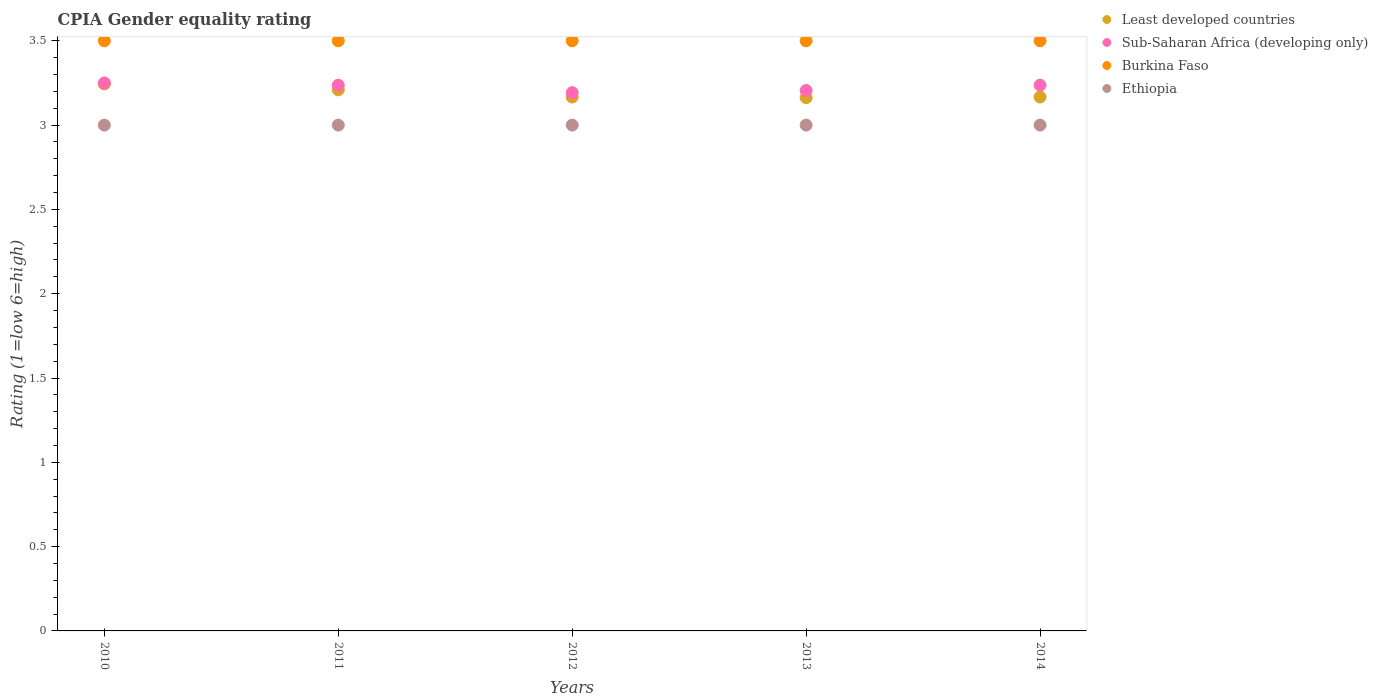Is the number of dotlines equal to the number of legend labels?
Offer a terse response. Yes. What is the CPIA rating in Least developed countries in 2010?
Keep it short and to the point. 3.24. In which year was the CPIA rating in Least developed countries maximum?
Provide a succinct answer. 2010. What is the total CPIA rating in Ethiopia in the graph?
Provide a short and direct response. 15. What is the difference between the CPIA rating in Least developed countries in 2012 and that in 2013?
Keep it short and to the point. 0. What is the difference between the CPIA rating in Burkina Faso in 2011 and the CPIA rating in Sub-Saharan Africa (developing only) in 2010?
Provide a succinct answer. 0.25. What is the average CPIA rating in Least developed countries per year?
Your response must be concise. 3.19. In the year 2011, what is the difference between the CPIA rating in Least developed countries and CPIA rating in Burkina Faso?
Your response must be concise. -0.29. What is the ratio of the CPIA rating in Least developed countries in 2010 to that in 2013?
Your answer should be very brief. 1.03. What is the difference between the highest and the second highest CPIA rating in Least developed countries?
Your answer should be very brief. 0.03. What is the difference between the highest and the lowest CPIA rating in Sub-Saharan Africa (developing only)?
Your response must be concise. 0.06. Is the sum of the CPIA rating in Burkina Faso in 2010 and 2013 greater than the maximum CPIA rating in Least developed countries across all years?
Make the answer very short. Yes. Is it the case that in every year, the sum of the CPIA rating in Ethiopia and CPIA rating in Least developed countries  is greater than the CPIA rating in Burkina Faso?
Your response must be concise. Yes. Does the CPIA rating in Ethiopia monotonically increase over the years?
Your answer should be very brief. No. How many dotlines are there?
Give a very brief answer. 4. Does the graph contain grids?
Make the answer very short. No. How many legend labels are there?
Ensure brevity in your answer.  4. What is the title of the graph?
Your answer should be very brief. CPIA Gender equality rating. What is the label or title of the Y-axis?
Your answer should be very brief. Rating (1=low 6=high). What is the Rating (1=low 6=high) of Least developed countries in 2010?
Keep it short and to the point. 3.24. What is the Rating (1=low 6=high) of Ethiopia in 2010?
Make the answer very short. 3. What is the Rating (1=low 6=high) of Least developed countries in 2011?
Provide a succinct answer. 3.21. What is the Rating (1=low 6=high) of Sub-Saharan Africa (developing only) in 2011?
Your response must be concise. 3.24. What is the Rating (1=low 6=high) of Burkina Faso in 2011?
Your response must be concise. 3.5. What is the Rating (1=low 6=high) in Least developed countries in 2012?
Keep it short and to the point. 3.17. What is the Rating (1=low 6=high) in Sub-Saharan Africa (developing only) in 2012?
Your answer should be compact. 3.19. What is the Rating (1=low 6=high) of Ethiopia in 2012?
Keep it short and to the point. 3. What is the Rating (1=low 6=high) in Least developed countries in 2013?
Provide a succinct answer. 3.16. What is the Rating (1=low 6=high) of Sub-Saharan Africa (developing only) in 2013?
Provide a short and direct response. 3.21. What is the Rating (1=low 6=high) of Burkina Faso in 2013?
Keep it short and to the point. 3.5. What is the Rating (1=low 6=high) in Least developed countries in 2014?
Your response must be concise. 3.17. What is the Rating (1=low 6=high) of Sub-Saharan Africa (developing only) in 2014?
Give a very brief answer. 3.24. What is the Rating (1=low 6=high) in Ethiopia in 2014?
Keep it short and to the point. 3. Across all years, what is the maximum Rating (1=low 6=high) in Least developed countries?
Your answer should be very brief. 3.24. Across all years, what is the maximum Rating (1=low 6=high) in Sub-Saharan Africa (developing only)?
Offer a terse response. 3.25. Across all years, what is the minimum Rating (1=low 6=high) of Least developed countries?
Your answer should be very brief. 3.16. Across all years, what is the minimum Rating (1=low 6=high) in Sub-Saharan Africa (developing only)?
Provide a short and direct response. 3.19. What is the total Rating (1=low 6=high) of Least developed countries in the graph?
Provide a short and direct response. 15.95. What is the total Rating (1=low 6=high) in Sub-Saharan Africa (developing only) in the graph?
Provide a short and direct response. 16.12. What is the total Rating (1=low 6=high) in Ethiopia in the graph?
Give a very brief answer. 15. What is the difference between the Rating (1=low 6=high) in Least developed countries in 2010 and that in 2011?
Ensure brevity in your answer.  0.03. What is the difference between the Rating (1=low 6=high) of Sub-Saharan Africa (developing only) in 2010 and that in 2011?
Your answer should be compact. 0.01. What is the difference between the Rating (1=low 6=high) in Burkina Faso in 2010 and that in 2011?
Offer a very short reply. 0. What is the difference between the Rating (1=low 6=high) of Least developed countries in 2010 and that in 2012?
Provide a succinct answer. 0.08. What is the difference between the Rating (1=low 6=high) of Sub-Saharan Africa (developing only) in 2010 and that in 2012?
Offer a very short reply. 0.06. What is the difference between the Rating (1=low 6=high) in Ethiopia in 2010 and that in 2012?
Offer a terse response. 0. What is the difference between the Rating (1=low 6=high) in Least developed countries in 2010 and that in 2013?
Your answer should be very brief. 0.08. What is the difference between the Rating (1=low 6=high) of Sub-Saharan Africa (developing only) in 2010 and that in 2013?
Your answer should be very brief. 0.04. What is the difference between the Rating (1=low 6=high) in Burkina Faso in 2010 and that in 2013?
Provide a succinct answer. 0. What is the difference between the Rating (1=low 6=high) of Ethiopia in 2010 and that in 2013?
Give a very brief answer. 0. What is the difference between the Rating (1=low 6=high) of Least developed countries in 2010 and that in 2014?
Provide a short and direct response. 0.08. What is the difference between the Rating (1=low 6=high) in Sub-Saharan Africa (developing only) in 2010 and that in 2014?
Make the answer very short. 0.01. What is the difference between the Rating (1=low 6=high) of Burkina Faso in 2010 and that in 2014?
Provide a short and direct response. 0. What is the difference between the Rating (1=low 6=high) in Ethiopia in 2010 and that in 2014?
Your response must be concise. 0. What is the difference between the Rating (1=low 6=high) in Least developed countries in 2011 and that in 2012?
Provide a short and direct response. 0.04. What is the difference between the Rating (1=low 6=high) in Sub-Saharan Africa (developing only) in 2011 and that in 2012?
Keep it short and to the point. 0.04. What is the difference between the Rating (1=low 6=high) in Burkina Faso in 2011 and that in 2012?
Keep it short and to the point. 0. What is the difference between the Rating (1=low 6=high) of Least developed countries in 2011 and that in 2013?
Ensure brevity in your answer.  0.05. What is the difference between the Rating (1=low 6=high) in Sub-Saharan Africa (developing only) in 2011 and that in 2013?
Provide a succinct answer. 0.03. What is the difference between the Rating (1=low 6=high) in Burkina Faso in 2011 and that in 2013?
Your answer should be compact. 0. What is the difference between the Rating (1=low 6=high) of Least developed countries in 2011 and that in 2014?
Give a very brief answer. 0.04. What is the difference between the Rating (1=low 6=high) in Sub-Saharan Africa (developing only) in 2011 and that in 2014?
Give a very brief answer. 0. What is the difference between the Rating (1=low 6=high) of Ethiopia in 2011 and that in 2014?
Provide a short and direct response. 0. What is the difference between the Rating (1=low 6=high) of Least developed countries in 2012 and that in 2013?
Your answer should be compact. 0. What is the difference between the Rating (1=low 6=high) in Sub-Saharan Africa (developing only) in 2012 and that in 2013?
Your response must be concise. -0.01. What is the difference between the Rating (1=low 6=high) in Least developed countries in 2012 and that in 2014?
Your answer should be very brief. 0. What is the difference between the Rating (1=low 6=high) of Sub-Saharan Africa (developing only) in 2012 and that in 2014?
Provide a short and direct response. -0.04. What is the difference between the Rating (1=low 6=high) in Ethiopia in 2012 and that in 2014?
Offer a terse response. 0. What is the difference between the Rating (1=low 6=high) of Least developed countries in 2013 and that in 2014?
Your response must be concise. -0. What is the difference between the Rating (1=low 6=high) in Sub-Saharan Africa (developing only) in 2013 and that in 2014?
Ensure brevity in your answer.  -0.03. What is the difference between the Rating (1=low 6=high) in Burkina Faso in 2013 and that in 2014?
Provide a succinct answer. 0. What is the difference between the Rating (1=low 6=high) in Least developed countries in 2010 and the Rating (1=low 6=high) in Sub-Saharan Africa (developing only) in 2011?
Keep it short and to the point. 0.01. What is the difference between the Rating (1=low 6=high) of Least developed countries in 2010 and the Rating (1=low 6=high) of Burkina Faso in 2011?
Offer a terse response. -0.26. What is the difference between the Rating (1=low 6=high) in Least developed countries in 2010 and the Rating (1=low 6=high) in Ethiopia in 2011?
Your answer should be very brief. 0.24. What is the difference between the Rating (1=low 6=high) of Sub-Saharan Africa (developing only) in 2010 and the Rating (1=low 6=high) of Burkina Faso in 2011?
Keep it short and to the point. -0.25. What is the difference between the Rating (1=low 6=high) of Burkina Faso in 2010 and the Rating (1=low 6=high) of Ethiopia in 2011?
Ensure brevity in your answer.  0.5. What is the difference between the Rating (1=low 6=high) of Least developed countries in 2010 and the Rating (1=low 6=high) of Sub-Saharan Africa (developing only) in 2012?
Offer a very short reply. 0.05. What is the difference between the Rating (1=low 6=high) in Least developed countries in 2010 and the Rating (1=low 6=high) in Burkina Faso in 2012?
Your response must be concise. -0.26. What is the difference between the Rating (1=low 6=high) of Least developed countries in 2010 and the Rating (1=low 6=high) of Ethiopia in 2012?
Provide a succinct answer. 0.24. What is the difference between the Rating (1=low 6=high) of Burkina Faso in 2010 and the Rating (1=low 6=high) of Ethiopia in 2012?
Make the answer very short. 0.5. What is the difference between the Rating (1=low 6=high) of Least developed countries in 2010 and the Rating (1=low 6=high) of Sub-Saharan Africa (developing only) in 2013?
Make the answer very short. 0.04. What is the difference between the Rating (1=low 6=high) of Least developed countries in 2010 and the Rating (1=low 6=high) of Burkina Faso in 2013?
Your answer should be compact. -0.26. What is the difference between the Rating (1=low 6=high) of Least developed countries in 2010 and the Rating (1=low 6=high) of Ethiopia in 2013?
Provide a succinct answer. 0.24. What is the difference between the Rating (1=low 6=high) of Least developed countries in 2010 and the Rating (1=low 6=high) of Sub-Saharan Africa (developing only) in 2014?
Provide a short and direct response. 0.01. What is the difference between the Rating (1=low 6=high) of Least developed countries in 2010 and the Rating (1=low 6=high) of Burkina Faso in 2014?
Give a very brief answer. -0.26. What is the difference between the Rating (1=low 6=high) of Least developed countries in 2010 and the Rating (1=low 6=high) of Ethiopia in 2014?
Give a very brief answer. 0.24. What is the difference between the Rating (1=low 6=high) of Sub-Saharan Africa (developing only) in 2010 and the Rating (1=low 6=high) of Burkina Faso in 2014?
Make the answer very short. -0.25. What is the difference between the Rating (1=low 6=high) of Sub-Saharan Africa (developing only) in 2010 and the Rating (1=low 6=high) of Ethiopia in 2014?
Your answer should be compact. 0.25. What is the difference between the Rating (1=low 6=high) in Least developed countries in 2011 and the Rating (1=low 6=high) in Sub-Saharan Africa (developing only) in 2012?
Your answer should be very brief. 0.02. What is the difference between the Rating (1=low 6=high) of Least developed countries in 2011 and the Rating (1=low 6=high) of Burkina Faso in 2012?
Give a very brief answer. -0.29. What is the difference between the Rating (1=low 6=high) in Least developed countries in 2011 and the Rating (1=low 6=high) in Ethiopia in 2012?
Ensure brevity in your answer.  0.21. What is the difference between the Rating (1=low 6=high) in Sub-Saharan Africa (developing only) in 2011 and the Rating (1=low 6=high) in Burkina Faso in 2012?
Keep it short and to the point. -0.26. What is the difference between the Rating (1=low 6=high) of Sub-Saharan Africa (developing only) in 2011 and the Rating (1=low 6=high) of Ethiopia in 2012?
Provide a succinct answer. 0.24. What is the difference between the Rating (1=low 6=high) in Least developed countries in 2011 and the Rating (1=low 6=high) in Sub-Saharan Africa (developing only) in 2013?
Your answer should be very brief. 0. What is the difference between the Rating (1=low 6=high) in Least developed countries in 2011 and the Rating (1=low 6=high) in Burkina Faso in 2013?
Your answer should be very brief. -0.29. What is the difference between the Rating (1=low 6=high) of Least developed countries in 2011 and the Rating (1=low 6=high) of Ethiopia in 2013?
Your response must be concise. 0.21. What is the difference between the Rating (1=low 6=high) in Sub-Saharan Africa (developing only) in 2011 and the Rating (1=low 6=high) in Burkina Faso in 2013?
Your answer should be very brief. -0.26. What is the difference between the Rating (1=low 6=high) in Sub-Saharan Africa (developing only) in 2011 and the Rating (1=low 6=high) in Ethiopia in 2013?
Ensure brevity in your answer.  0.24. What is the difference between the Rating (1=low 6=high) in Least developed countries in 2011 and the Rating (1=low 6=high) in Sub-Saharan Africa (developing only) in 2014?
Make the answer very short. -0.03. What is the difference between the Rating (1=low 6=high) in Least developed countries in 2011 and the Rating (1=low 6=high) in Burkina Faso in 2014?
Provide a short and direct response. -0.29. What is the difference between the Rating (1=low 6=high) of Least developed countries in 2011 and the Rating (1=low 6=high) of Ethiopia in 2014?
Offer a terse response. 0.21. What is the difference between the Rating (1=low 6=high) of Sub-Saharan Africa (developing only) in 2011 and the Rating (1=low 6=high) of Burkina Faso in 2014?
Your answer should be compact. -0.26. What is the difference between the Rating (1=low 6=high) of Sub-Saharan Africa (developing only) in 2011 and the Rating (1=low 6=high) of Ethiopia in 2014?
Your response must be concise. 0.24. What is the difference between the Rating (1=low 6=high) of Least developed countries in 2012 and the Rating (1=low 6=high) of Sub-Saharan Africa (developing only) in 2013?
Keep it short and to the point. -0.04. What is the difference between the Rating (1=low 6=high) in Least developed countries in 2012 and the Rating (1=low 6=high) in Burkina Faso in 2013?
Your answer should be compact. -0.33. What is the difference between the Rating (1=low 6=high) of Sub-Saharan Africa (developing only) in 2012 and the Rating (1=low 6=high) of Burkina Faso in 2013?
Keep it short and to the point. -0.31. What is the difference between the Rating (1=low 6=high) of Sub-Saharan Africa (developing only) in 2012 and the Rating (1=low 6=high) of Ethiopia in 2013?
Your answer should be very brief. 0.19. What is the difference between the Rating (1=low 6=high) of Burkina Faso in 2012 and the Rating (1=low 6=high) of Ethiopia in 2013?
Offer a very short reply. 0.5. What is the difference between the Rating (1=low 6=high) of Least developed countries in 2012 and the Rating (1=low 6=high) of Sub-Saharan Africa (developing only) in 2014?
Your response must be concise. -0.07. What is the difference between the Rating (1=low 6=high) of Least developed countries in 2012 and the Rating (1=low 6=high) of Burkina Faso in 2014?
Make the answer very short. -0.33. What is the difference between the Rating (1=low 6=high) in Sub-Saharan Africa (developing only) in 2012 and the Rating (1=low 6=high) in Burkina Faso in 2014?
Give a very brief answer. -0.31. What is the difference between the Rating (1=low 6=high) in Sub-Saharan Africa (developing only) in 2012 and the Rating (1=low 6=high) in Ethiopia in 2014?
Your response must be concise. 0.19. What is the difference between the Rating (1=low 6=high) of Burkina Faso in 2012 and the Rating (1=low 6=high) of Ethiopia in 2014?
Your response must be concise. 0.5. What is the difference between the Rating (1=low 6=high) in Least developed countries in 2013 and the Rating (1=low 6=high) in Sub-Saharan Africa (developing only) in 2014?
Make the answer very short. -0.07. What is the difference between the Rating (1=low 6=high) of Least developed countries in 2013 and the Rating (1=low 6=high) of Burkina Faso in 2014?
Your answer should be compact. -0.34. What is the difference between the Rating (1=low 6=high) in Least developed countries in 2013 and the Rating (1=low 6=high) in Ethiopia in 2014?
Provide a succinct answer. 0.16. What is the difference between the Rating (1=low 6=high) of Sub-Saharan Africa (developing only) in 2013 and the Rating (1=low 6=high) of Burkina Faso in 2014?
Give a very brief answer. -0.29. What is the difference between the Rating (1=low 6=high) in Sub-Saharan Africa (developing only) in 2013 and the Rating (1=low 6=high) in Ethiopia in 2014?
Keep it short and to the point. 0.21. What is the average Rating (1=low 6=high) in Least developed countries per year?
Your response must be concise. 3.19. What is the average Rating (1=low 6=high) in Sub-Saharan Africa (developing only) per year?
Your response must be concise. 3.22. What is the average Rating (1=low 6=high) of Burkina Faso per year?
Offer a very short reply. 3.5. In the year 2010, what is the difference between the Rating (1=low 6=high) in Least developed countries and Rating (1=low 6=high) in Sub-Saharan Africa (developing only)?
Offer a very short reply. -0.01. In the year 2010, what is the difference between the Rating (1=low 6=high) of Least developed countries and Rating (1=low 6=high) of Burkina Faso?
Provide a succinct answer. -0.26. In the year 2010, what is the difference between the Rating (1=low 6=high) of Least developed countries and Rating (1=low 6=high) of Ethiopia?
Make the answer very short. 0.24. In the year 2010, what is the difference between the Rating (1=low 6=high) in Burkina Faso and Rating (1=low 6=high) in Ethiopia?
Your answer should be very brief. 0.5. In the year 2011, what is the difference between the Rating (1=low 6=high) of Least developed countries and Rating (1=low 6=high) of Sub-Saharan Africa (developing only)?
Your answer should be compact. -0.03. In the year 2011, what is the difference between the Rating (1=low 6=high) in Least developed countries and Rating (1=low 6=high) in Burkina Faso?
Make the answer very short. -0.29. In the year 2011, what is the difference between the Rating (1=low 6=high) in Least developed countries and Rating (1=low 6=high) in Ethiopia?
Your response must be concise. 0.21. In the year 2011, what is the difference between the Rating (1=low 6=high) of Sub-Saharan Africa (developing only) and Rating (1=low 6=high) of Burkina Faso?
Provide a succinct answer. -0.26. In the year 2011, what is the difference between the Rating (1=low 6=high) in Sub-Saharan Africa (developing only) and Rating (1=low 6=high) in Ethiopia?
Your answer should be compact. 0.24. In the year 2012, what is the difference between the Rating (1=low 6=high) in Least developed countries and Rating (1=low 6=high) in Sub-Saharan Africa (developing only)?
Your response must be concise. -0.03. In the year 2012, what is the difference between the Rating (1=low 6=high) in Least developed countries and Rating (1=low 6=high) in Ethiopia?
Provide a succinct answer. 0.17. In the year 2012, what is the difference between the Rating (1=low 6=high) in Sub-Saharan Africa (developing only) and Rating (1=low 6=high) in Burkina Faso?
Ensure brevity in your answer.  -0.31. In the year 2012, what is the difference between the Rating (1=low 6=high) of Sub-Saharan Africa (developing only) and Rating (1=low 6=high) of Ethiopia?
Give a very brief answer. 0.19. In the year 2013, what is the difference between the Rating (1=low 6=high) in Least developed countries and Rating (1=low 6=high) in Sub-Saharan Africa (developing only)?
Your response must be concise. -0.04. In the year 2013, what is the difference between the Rating (1=low 6=high) in Least developed countries and Rating (1=low 6=high) in Burkina Faso?
Provide a succinct answer. -0.34. In the year 2013, what is the difference between the Rating (1=low 6=high) of Least developed countries and Rating (1=low 6=high) of Ethiopia?
Offer a terse response. 0.16. In the year 2013, what is the difference between the Rating (1=low 6=high) in Sub-Saharan Africa (developing only) and Rating (1=low 6=high) in Burkina Faso?
Ensure brevity in your answer.  -0.29. In the year 2013, what is the difference between the Rating (1=low 6=high) in Sub-Saharan Africa (developing only) and Rating (1=low 6=high) in Ethiopia?
Ensure brevity in your answer.  0.21. In the year 2013, what is the difference between the Rating (1=low 6=high) in Burkina Faso and Rating (1=low 6=high) in Ethiopia?
Your response must be concise. 0.5. In the year 2014, what is the difference between the Rating (1=low 6=high) in Least developed countries and Rating (1=low 6=high) in Sub-Saharan Africa (developing only)?
Provide a succinct answer. -0.07. In the year 2014, what is the difference between the Rating (1=low 6=high) of Sub-Saharan Africa (developing only) and Rating (1=low 6=high) of Burkina Faso?
Offer a terse response. -0.26. In the year 2014, what is the difference between the Rating (1=low 6=high) in Sub-Saharan Africa (developing only) and Rating (1=low 6=high) in Ethiopia?
Offer a very short reply. 0.24. In the year 2014, what is the difference between the Rating (1=low 6=high) in Burkina Faso and Rating (1=low 6=high) in Ethiopia?
Ensure brevity in your answer.  0.5. What is the ratio of the Rating (1=low 6=high) of Least developed countries in 2010 to that in 2011?
Your answer should be compact. 1.01. What is the ratio of the Rating (1=low 6=high) in Sub-Saharan Africa (developing only) in 2010 to that in 2011?
Your answer should be compact. 1. What is the ratio of the Rating (1=low 6=high) in Least developed countries in 2010 to that in 2012?
Your answer should be very brief. 1.02. What is the ratio of the Rating (1=low 6=high) in Sub-Saharan Africa (developing only) in 2010 to that in 2012?
Provide a short and direct response. 1.02. What is the ratio of the Rating (1=low 6=high) in Burkina Faso in 2010 to that in 2012?
Your response must be concise. 1. What is the ratio of the Rating (1=low 6=high) of Ethiopia in 2010 to that in 2012?
Your response must be concise. 1. What is the ratio of the Rating (1=low 6=high) of Least developed countries in 2010 to that in 2013?
Offer a terse response. 1.03. What is the ratio of the Rating (1=low 6=high) of Burkina Faso in 2010 to that in 2013?
Ensure brevity in your answer.  1. What is the ratio of the Rating (1=low 6=high) of Least developed countries in 2010 to that in 2014?
Your answer should be very brief. 1.02. What is the ratio of the Rating (1=low 6=high) of Sub-Saharan Africa (developing only) in 2010 to that in 2014?
Offer a terse response. 1. What is the ratio of the Rating (1=low 6=high) of Burkina Faso in 2010 to that in 2014?
Your answer should be very brief. 1. What is the ratio of the Rating (1=low 6=high) of Least developed countries in 2011 to that in 2012?
Your response must be concise. 1.01. What is the ratio of the Rating (1=low 6=high) of Sub-Saharan Africa (developing only) in 2011 to that in 2012?
Your response must be concise. 1.01. What is the ratio of the Rating (1=low 6=high) in Burkina Faso in 2011 to that in 2012?
Your response must be concise. 1. What is the ratio of the Rating (1=low 6=high) in Least developed countries in 2011 to that in 2013?
Your answer should be compact. 1.01. What is the ratio of the Rating (1=low 6=high) of Sub-Saharan Africa (developing only) in 2011 to that in 2013?
Make the answer very short. 1.01. What is the ratio of the Rating (1=low 6=high) in Burkina Faso in 2011 to that in 2013?
Provide a succinct answer. 1. What is the ratio of the Rating (1=low 6=high) of Ethiopia in 2011 to that in 2013?
Your response must be concise. 1. What is the ratio of the Rating (1=low 6=high) in Least developed countries in 2011 to that in 2014?
Your response must be concise. 1.01. What is the ratio of the Rating (1=low 6=high) in Sub-Saharan Africa (developing only) in 2011 to that in 2014?
Provide a succinct answer. 1. What is the ratio of the Rating (1=low 6=high) of Burkina Faso in 2012 to that in 2013?
Your answer should be very brief. 1. What is the ratio of the Rating (1=low 6=high) of Ethiopia in 2012 to that in 2013?
Your answer should be very brief. 1. What is the ratio of the Rating (1=low 6=high) in Sub-Saharan Africa (developing only) in 2012 to that in 2014?
Your answer should be very brief. 0.99. What is the ratio of the Rating (1=low 6=high) in Burkina Faso in 2012 to that in 2014?
Your response must be concise. 1. What is the ratio of the Rating (1=low 6=high) of Least developed countries in 2013 to that in 2014?
Make the answer very short. 1. What is the ratio of the Rating (1=low 6=high) in Sub-Saharan Africa (developing only) in 2013 to that in 2014?
Keep it short and to the point. 0.99. What is the ratio of the Rating (1=low 6=high) in Burkina Faso in 2013 to that in 2014?
Provide a short and direct response. 1. What is the difference between the highest and the second highest Rating (1=low 6=high) in Least developed countries?
Your response must be concise. 0.03. What is the difference between the highest and the second highest Rating (1=low 6=high) in Sub-Saharan Africa (developing only)?
Your answer should be very brief. 0.01. What is the difference between the highest and the lowest Rating (1=low 6=high) in Least developed countries?
Give a very brief answer. 0.08. What is the difference between the highest and the lowest Rating (1=low 6=high) in Sub-Saharan Africa (developing only)?
Your response must be concise. 0.06. 